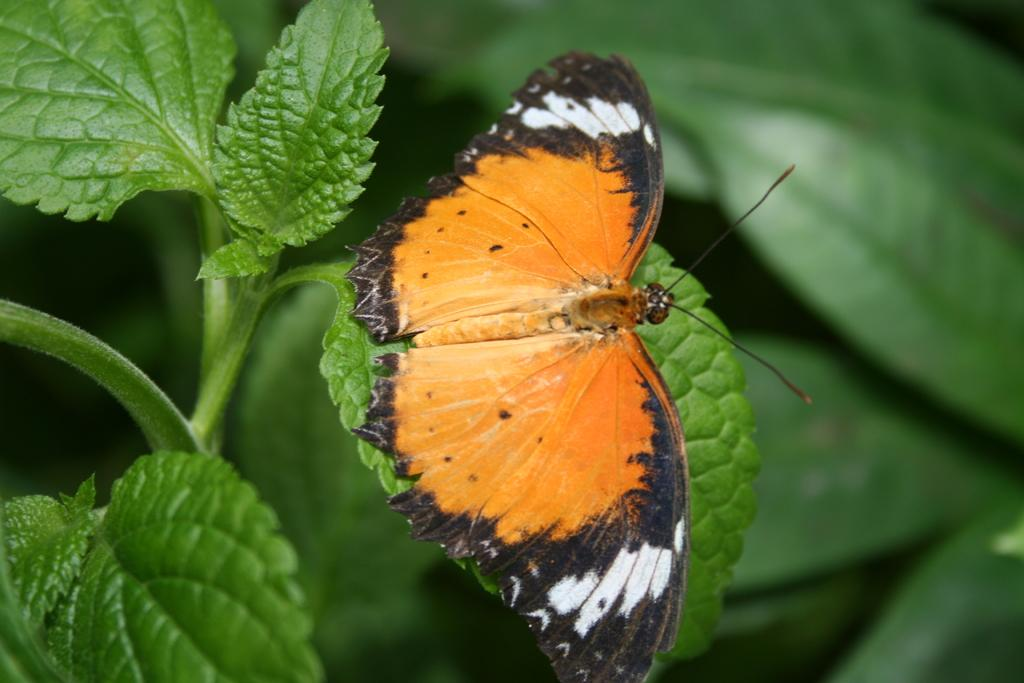What is the main subject of the image? The main subject of the image is a butterfly. Where is the butterfly located in the image? The butterfly is on the leaf of a plant. What type of humor can be seen in the image? There is no humor present in the image; it features a butterfly on a leaf. What adjustments need to be made to the plant in the image? There is no indication in the image that any adjustments need to be made to the plant. 